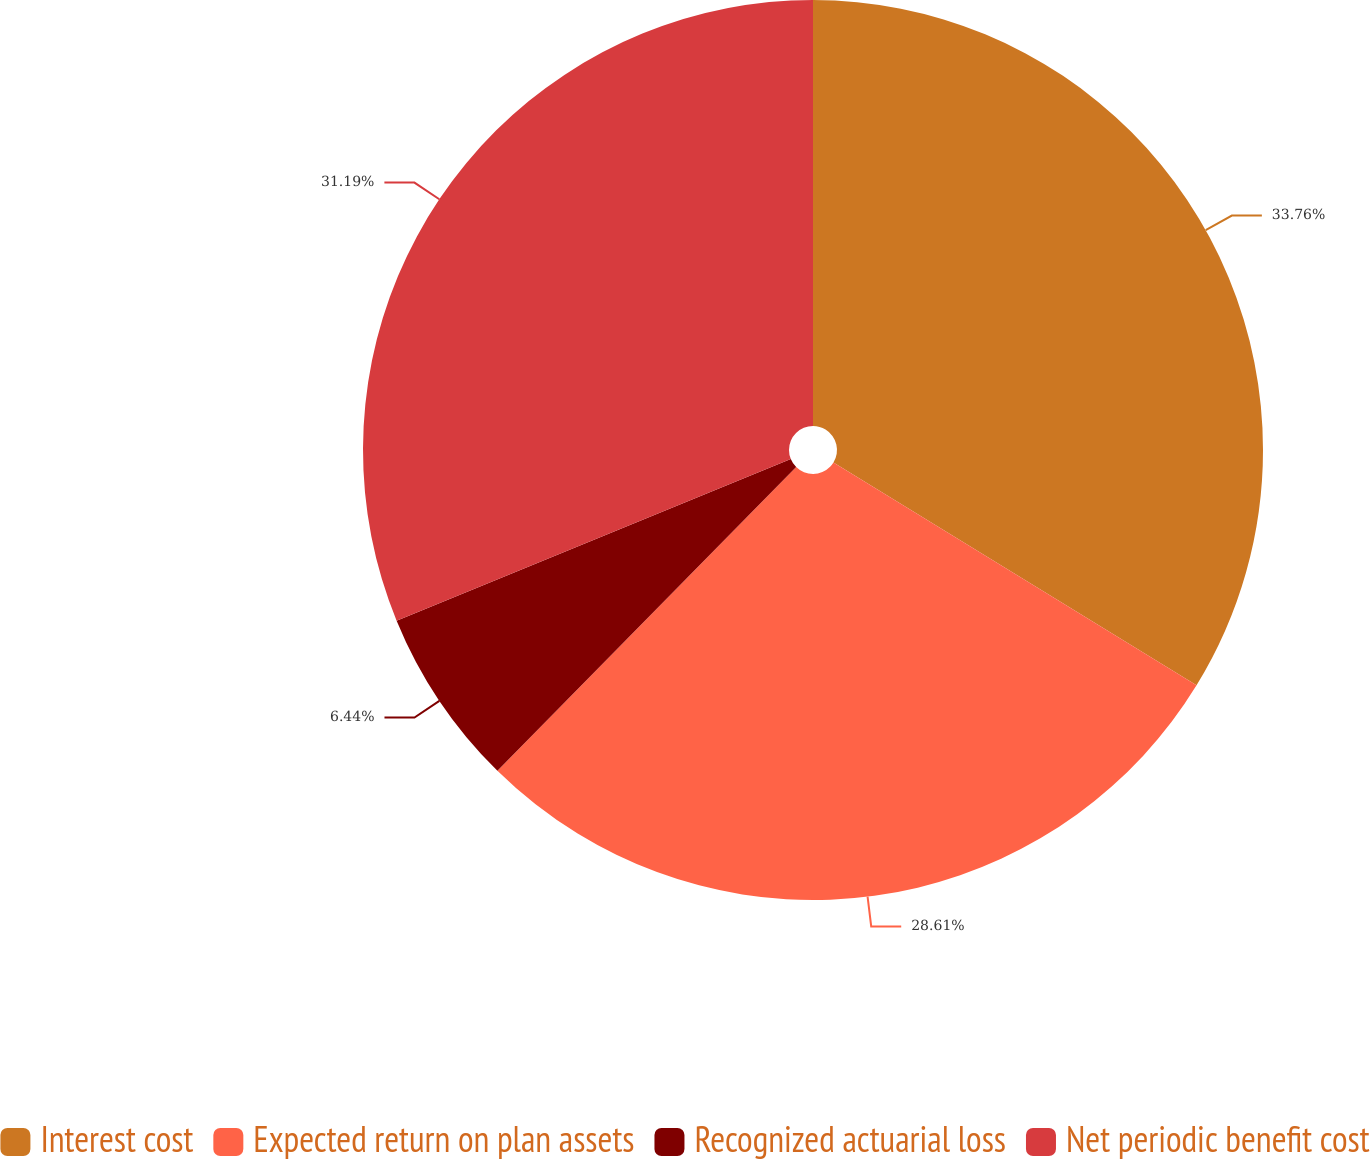<chart> <loc_0><loc_0><loc_500><loc_500><pie_chart><fcel>Interest cost<fcel>Expected return on plan assets<fcel>Recognized actuarial loss<fcel>Net periodic benefit cost<nl><fcel>33.76%<fcel>28.61%<fcel>6.44%<fcel>31.19%<nl></chart> 